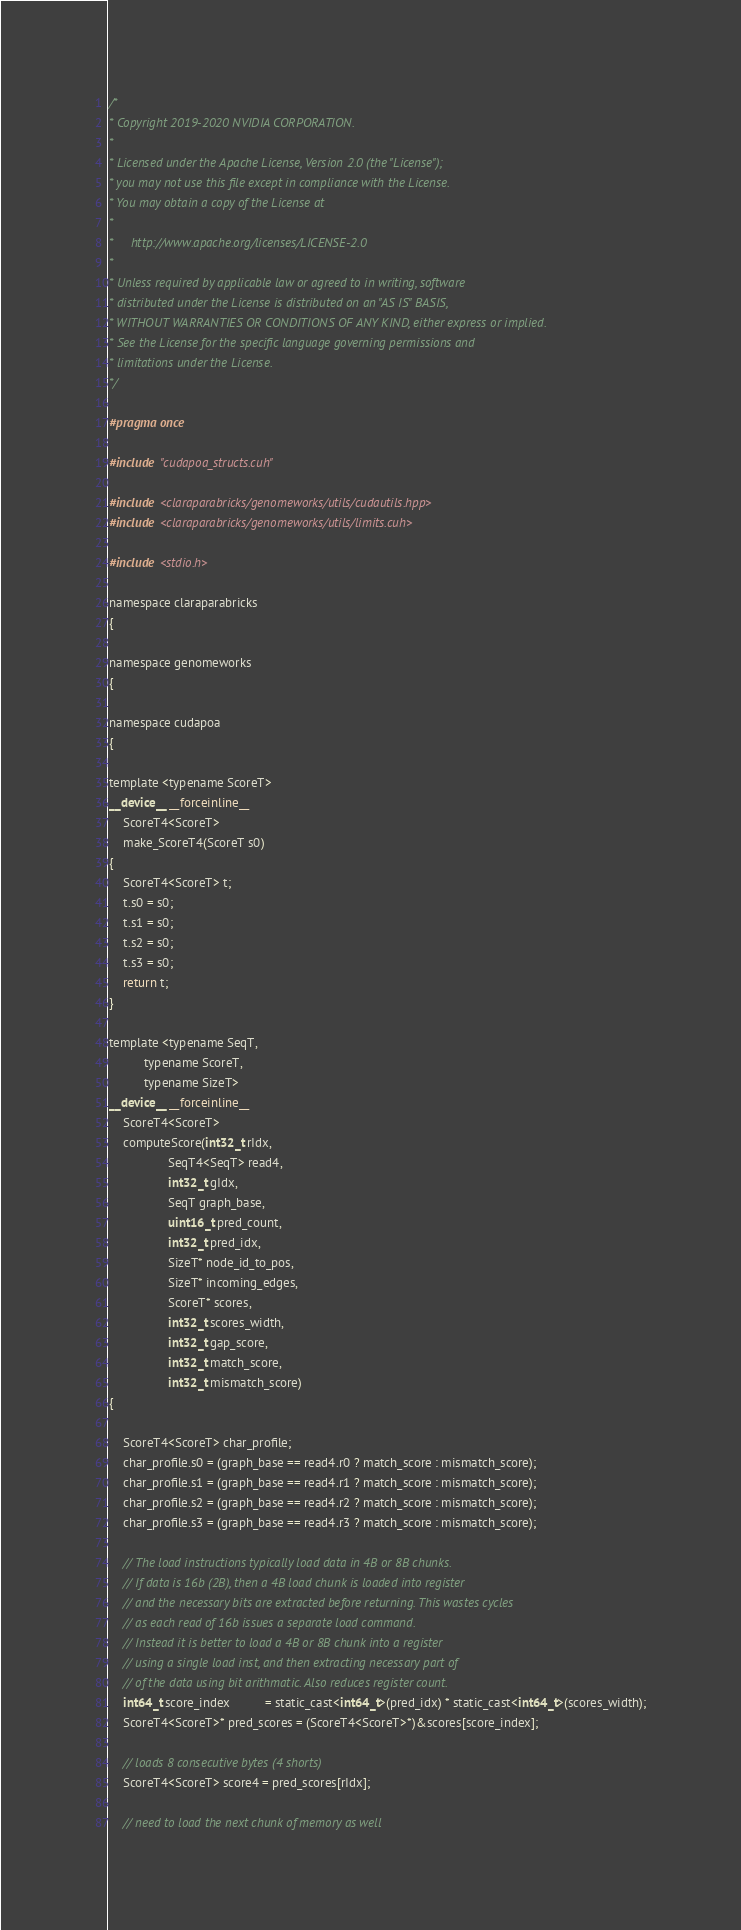<code> <loc_0><loc_0><loc_500><loc_500><_Cuda_>/*
* Copyright 2019-2020 NVIDIA CORPORATION.
*
* Licensed under the Apache License, Version 2.0 (the "License");
* you may not use this file except in compliance with the License.
* You may obtain a copy of the License at
*
*     http://www.apache.org/licenses/LICENSE-2.0
*
* Unless required by applicable law or agreed to in writing, software
* distributed under the License is distributed on an "AS IS" BASIS,
* WITHOUT WARRANTIES OR CONDITIONS OF ANY KIND, either express or implied.
* See the License for the specific language governing permissions and
* limitations under the License.
*/

#pragma once

#include "cudapoa_structs.cuh"

#include <claraparabricks/genomeworks/utils/cudautils.hpp>
#include <claraparabricks/genomeworks/utils/limits.cuh>

#include <stdio.h>

namespace claraparabricks
{

namespace genomeworks
{

namespace cudapoa
{

template <typename ScoreT>
__device__ __forceinline__
    ScoreT4<ScoreT>
    make_ScoreT4(ScoreT s0)
{
    ScoreT4<ScoreT> t;
    t.s0 = s0;
    t.s1 = s0;
    t.s2 = s0;
    t.s3 = s0;
    return t;
}

template <typename SeqT,
          typename ScoreT,
          typename SizeT>
__device__ __forceinline__
    ScoreT4<ScoreT>
    computeScore(int32_t rIdx,
                 SeqT4<SeqT> read4,
                 int32_t gIdx,
                 SeqT graph_base,
                 uint16_t pred_count,
                 int32_t pred_idx,
                 SizeT* node_id_to_pos,
                 SizeT* incoming_edges,
                 ScoreT* scores,
                 int32_t scores_width,
                 int32_t gap_score,
                 int32_t match_score,
                 int32_t mismatch_score)
{

    ScoreT4<ScoreT> char_profile;
    char_profile.s0 = (graph_base == read4.r0 ? match_score : mismatch_score);
    char_profile.s1 = (graph_base == read4.r1 ? match_score : mismatch_score);
    char_profile.s2 = (graph_base == read4.r2 ? match_score : mismatch_score);
    char_profile.s3 = (graph_base == read4.r3 ? match_score : mismatch_score);

    // The load instructions typically load data in 4B or 8B chunks.
    // If data is 16b (2B), then a 4B load chunk is loaded into register
    // and the necessary bits are extracted before returning. This wastes cycles
    // as each read of 16b issues a separate load command.
    // Instead it is better to load a 4B or 8B chunk into a register
    // using a single load inst, and then extracting necessary part of
    // of the data using bit arithmatic. Also reduces register count.
    int64_t score_index          = static_cast<int64_t>(pred_idx) * static_cast<int64_t>(scores_width);
    ScoreT4<ScoreT>* pred_scores = (ScoreT4<ScoreT>*)&scores[score_index];

    // loads 8 consecutive bytes (4 shorts)
    ScoreT4<ScoreT> score4 = pred_scores[rIdx];

    // need to load the next chunk of memory as well</code> 